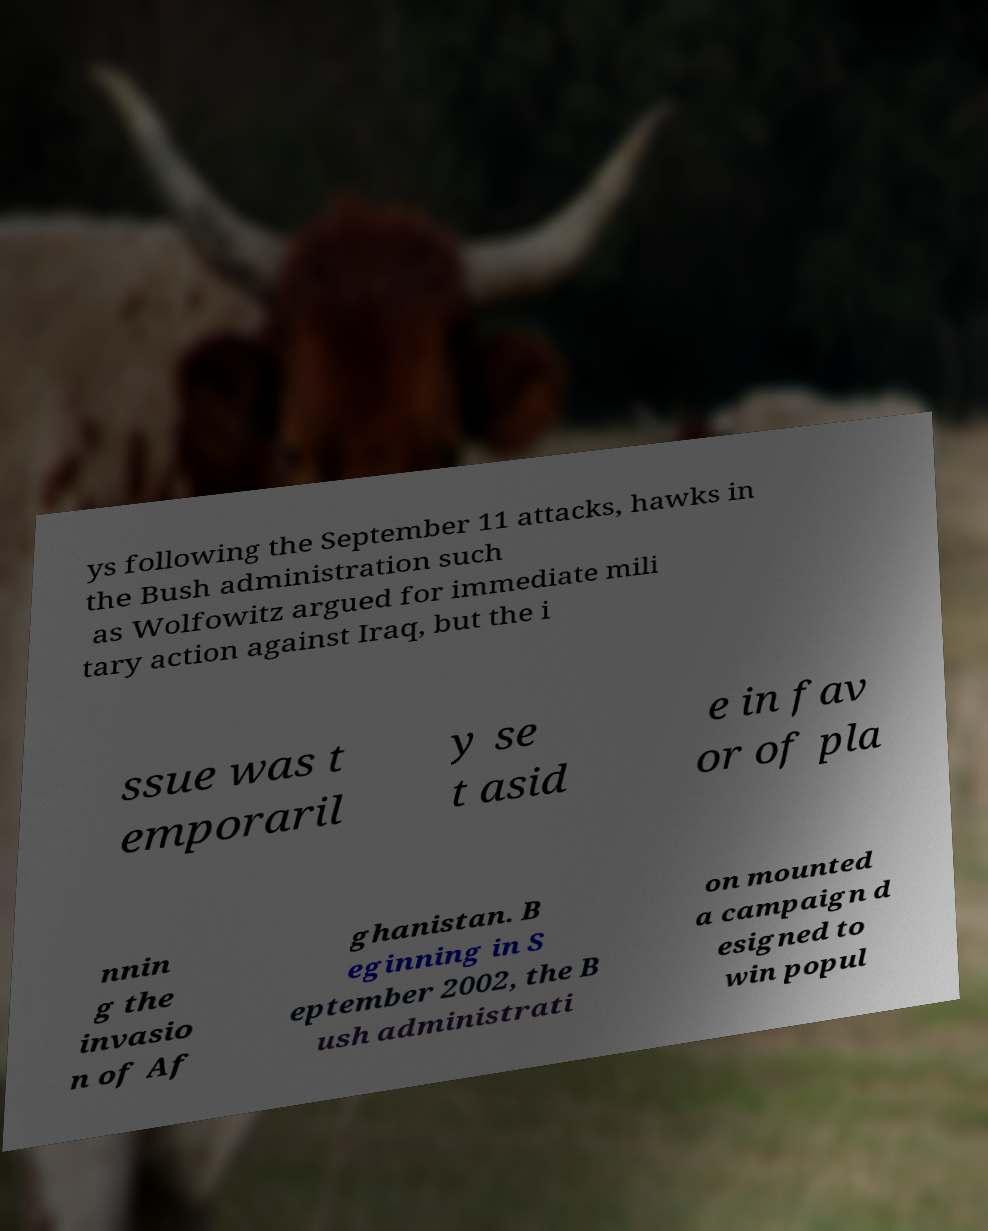Could you assist in decoding the text presented in this image and type it out clearly? ys following the September 11 attacks, hawks in the Bush administration such as Wolfowitz argued for immediate mili tary action against Iraq, but the i ssue was t emporaril y se t asid e in fav or of pla nnin g the invasio n of Af ghanistan. B eginning in S eptember 2002, the B ush administrati on mounted a campaign d esigned to win popul 